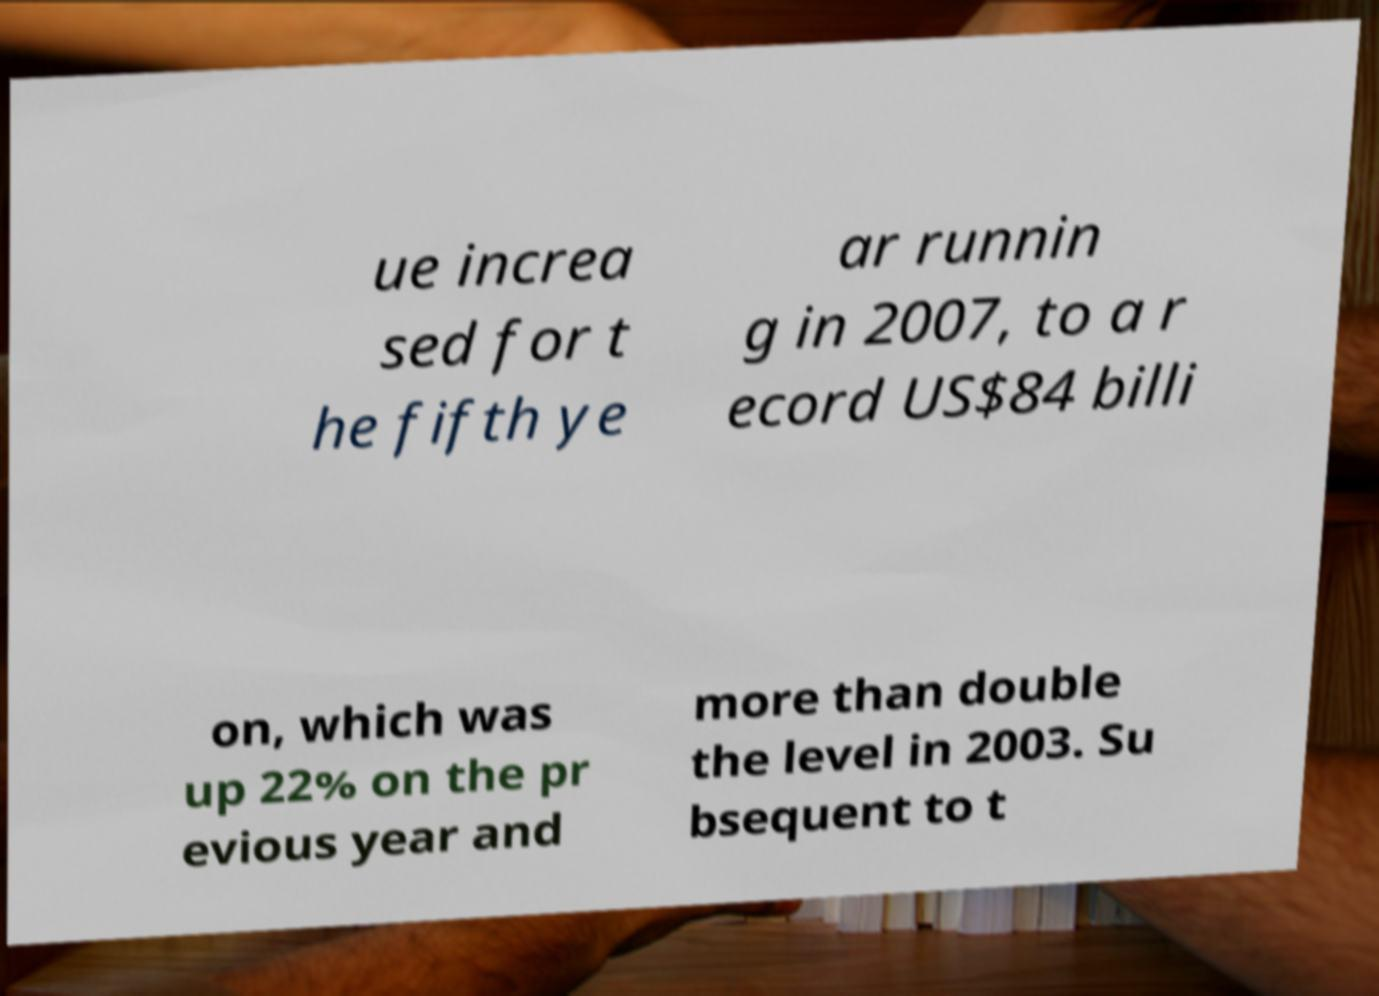Please identify and transcribe the text found in this image. ue increa sed for t he fifth ye ar runnin g in 2007, to a r ecord US$84 billi on, which was up 22% on the pr evious year and more than double the level in 2003. Su bsequent to t 